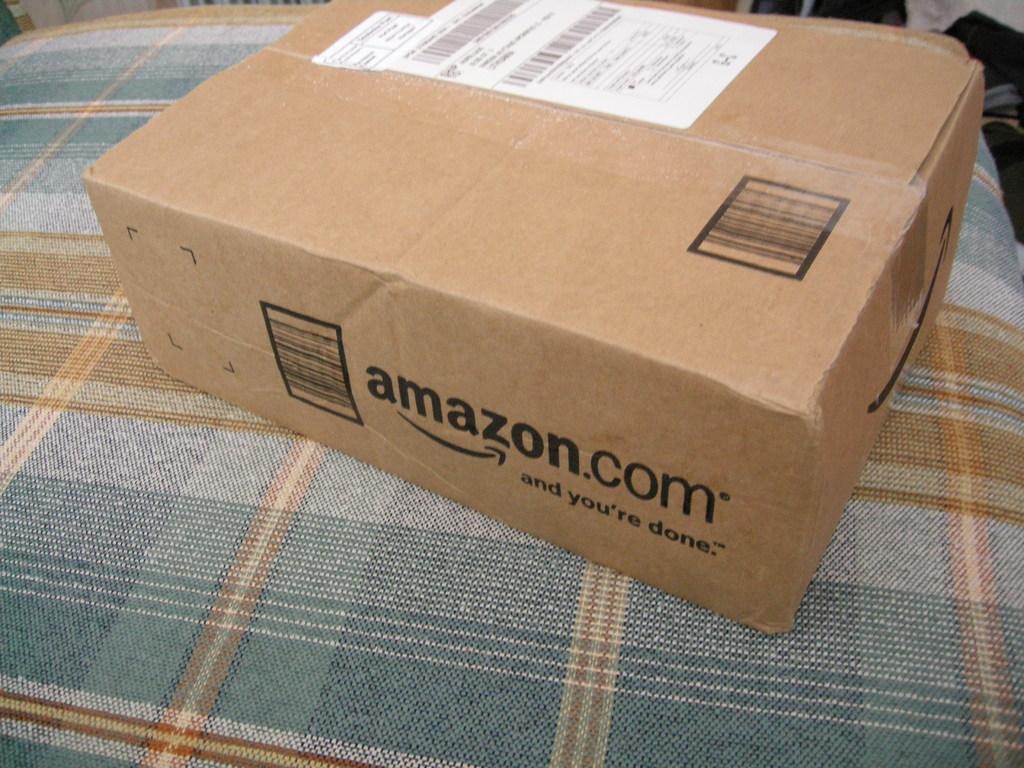What company shipped this item?
Make the answer very short. Amazon. 